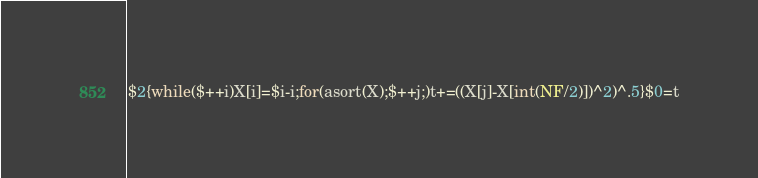<code> <loc_0><loc_0><loc_500><loc_500><_Awk_>$2{while($++i)X[i]=$i-i;for(asort(X);$++j;)t+=((X[j]-X[int(NF/2)])^2)^.5}$0=t</code> 